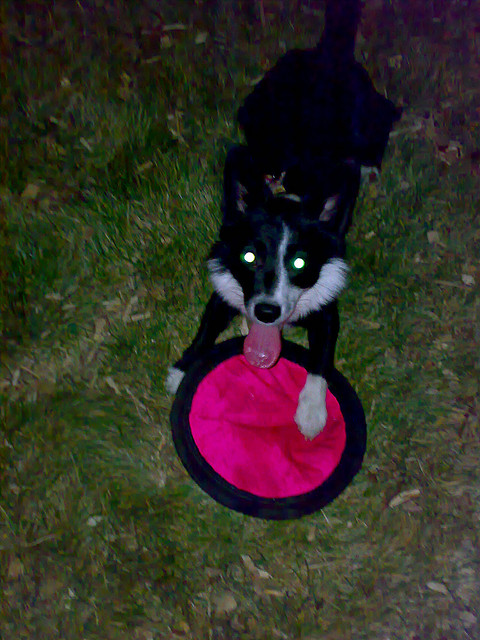<image>What type of dog is shown? I don't know what type of dog is shown. It can be an australian shepherd, a border collie, or a husky. Did the dog catch the frisbee? It is ambiguous whether the dog caught the frisbee or not. Did the dog catch the frisbee? I don't know if the dog caught the frisbee. It is ambiguous based on the given answers. What type of dog is shown? I am not sure what type of dog is shown. It could be a puppy, Australian shepherd, mutt, border collie, husky, collie, or black and white. 